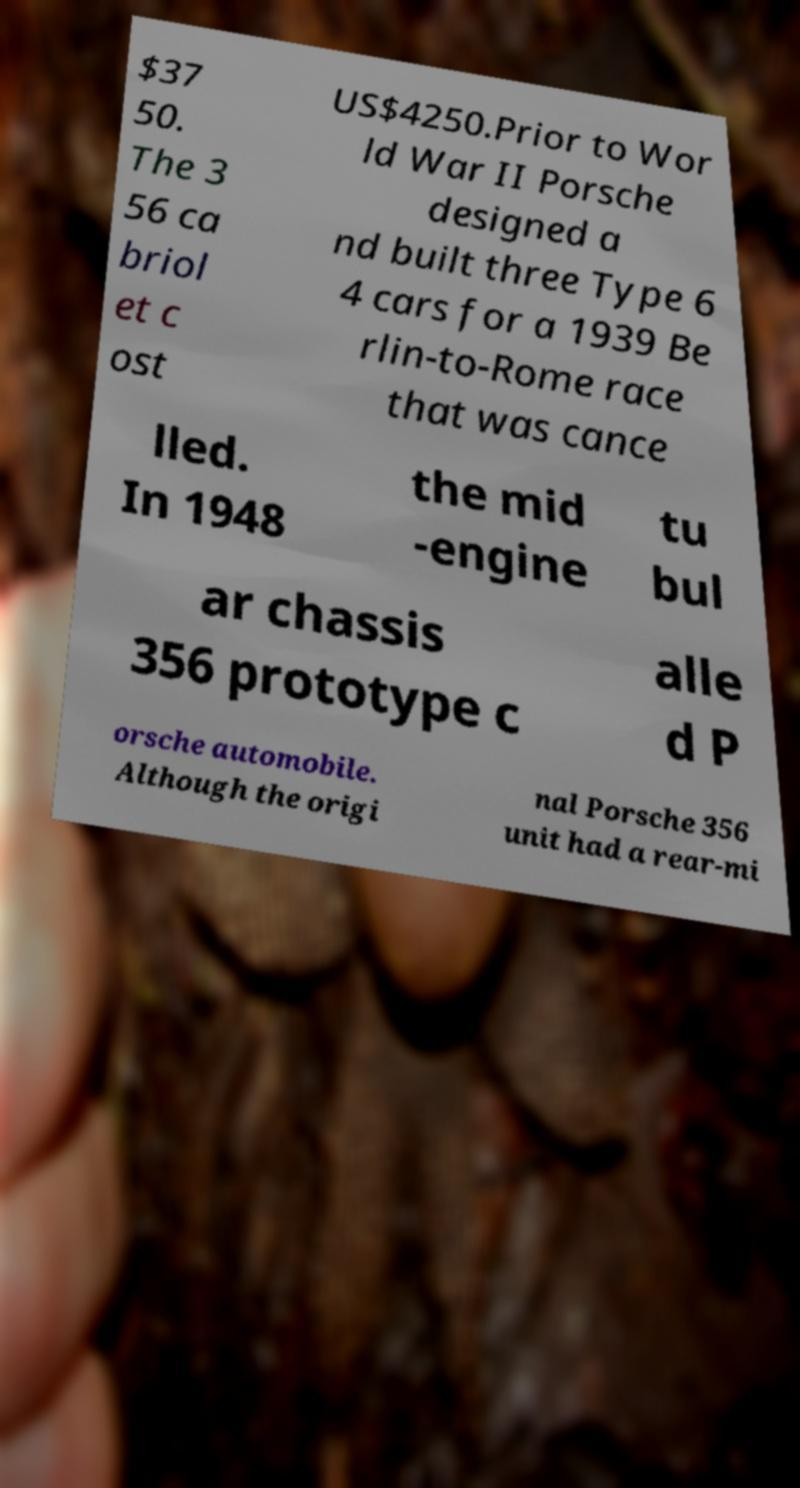Could you assist in decoding the text presented in this image and type it out clearly? $37 50. The 3 56 ca briol et c ost US$4250.Prior to Wor ld War II Porsche designed a nd built three Type 6 4 cars for a 1939 Be rlin-to-Rome race that was cance lled. In 1948 the mid -engine tu bul ar chassis 356 prototype c alle d P orsche automobile. Although the origi nal Porsche 356 unit had a rear-mi 